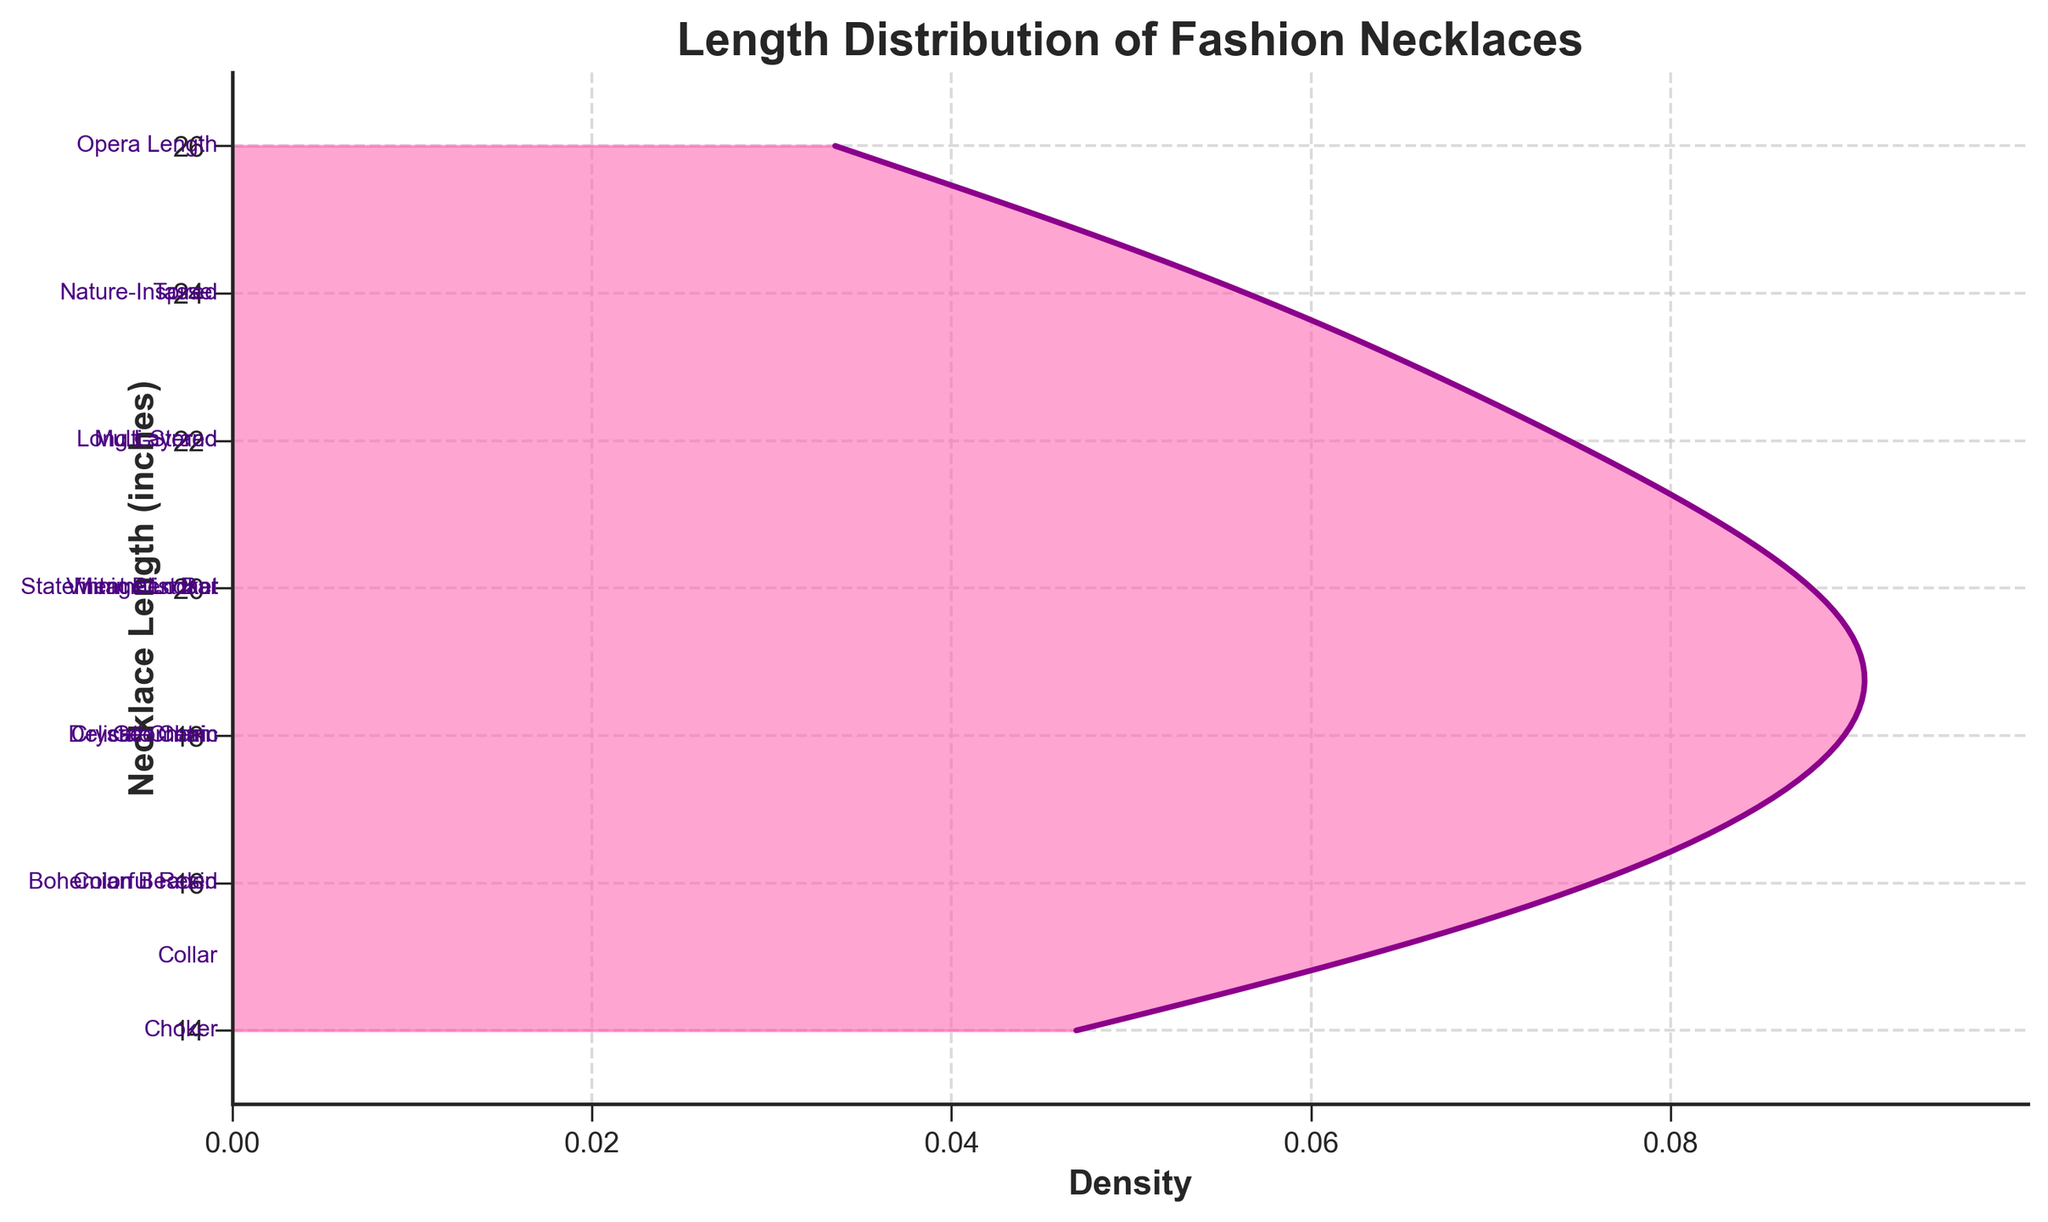What is the title of the plot? The title of the plot is displayed prominently at the top of the figure. It reads "Length Distribution of Fashion Necklaces", which indicates the content of the plot.
Answer: Length Distribution of Fashion Necklaces What does the x-axis represent? The x-axis is labeled as "Density" and it represents the estimated density of necklace lengths. This axis shows the probability density function values derived from the data.
Answer: Density What is the range of the y-axis? The y-axis is labeled as "Necklace Length (inches)" and its range can be determined by looking at the minimum and maximum values on this axis, which spans from 13 to 27 inches.
Answer: 13 to 27 inches Which necklace style has the shortest length? The shortest length corresponds to the lowest position on the y-axis. The label "Choker" appears at this position, indicating it has the shortest length.
Answer: Choker Which necklace style appears at a length of 20 inches? At the 20 inches mark on the y-axis, several styles are annotated. By examining the annotations, the styles "Statement Pendant", "Vintage Locket", and "Minimalist Bar" can be seen.
Answer: Statement Pendant, Vintage Locket, Minimalist Bar Which necklace style corresponds to the highest density region? The highest density region is where the pink shaded area is widest on the plot. This region centers around 18 inches as seen, and by checking the nearest annotations, the styles "Delicate Chain", "Crystal Charm", and "Geometric" correspond to this length.
Answer: Delicate Chain, Crystal Charm, Geometric What is the median length distribution for the necklaces? The median length can be found by identifying the point that divides the area under the density curve into two equal halves. The highest density lies around 18 inches, suggesting the median length is approximately 18 inches.
Answer: 18 inches How many necklace styles are annotated on the plot? To find the number of styles, count each unique annotation along the y-axis. By checking the annotations, there are a total of 15 unique necklace styles labeled.
Answer: 15 Which necklace style is annotated at 24 inches? By locating the 24 inches mark on the y-axis, the annotations "Tassel" and "Nature-Inspired" can be seen next to this length.
Answer: Tassel, Nature-Inspired How would you describe the overall shape of the density curve? The overall shape of the density curve is determined by the plot of the function. It shows a peak around 18 inches, suggesting a unimodal distribution with a higher density around this value and tapering off as it moves towards the extremes.
Answer: Unimodal with a peak around 18 inches 